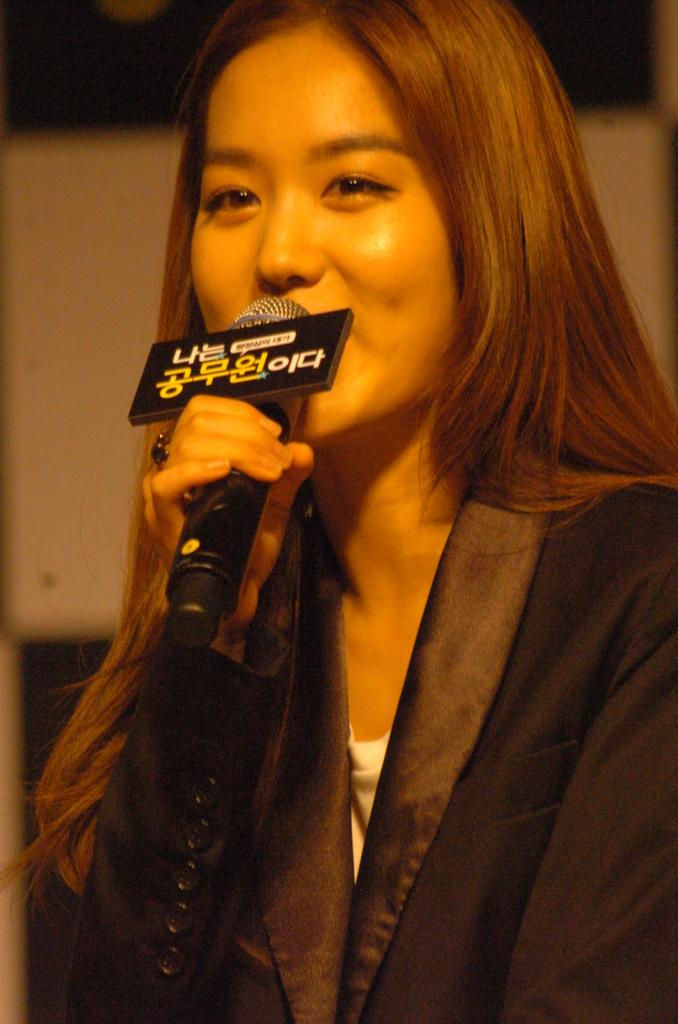Who is the main subject in the image? There is a woman in the image. What is the woman holding in her hands? The woman is holding a microphone in her hands. What might the woman be doing with the microphone? It appears that the woman is speaking, as she is holding a microphone. Can you see any ocean waves in the image? No, there is no ocean or ocean waves present in the image. What type of hair is the woman wearing in the image? There is no information about the woman's hair in the provided facts, so we cannot determine the type of hair she is wearing. 